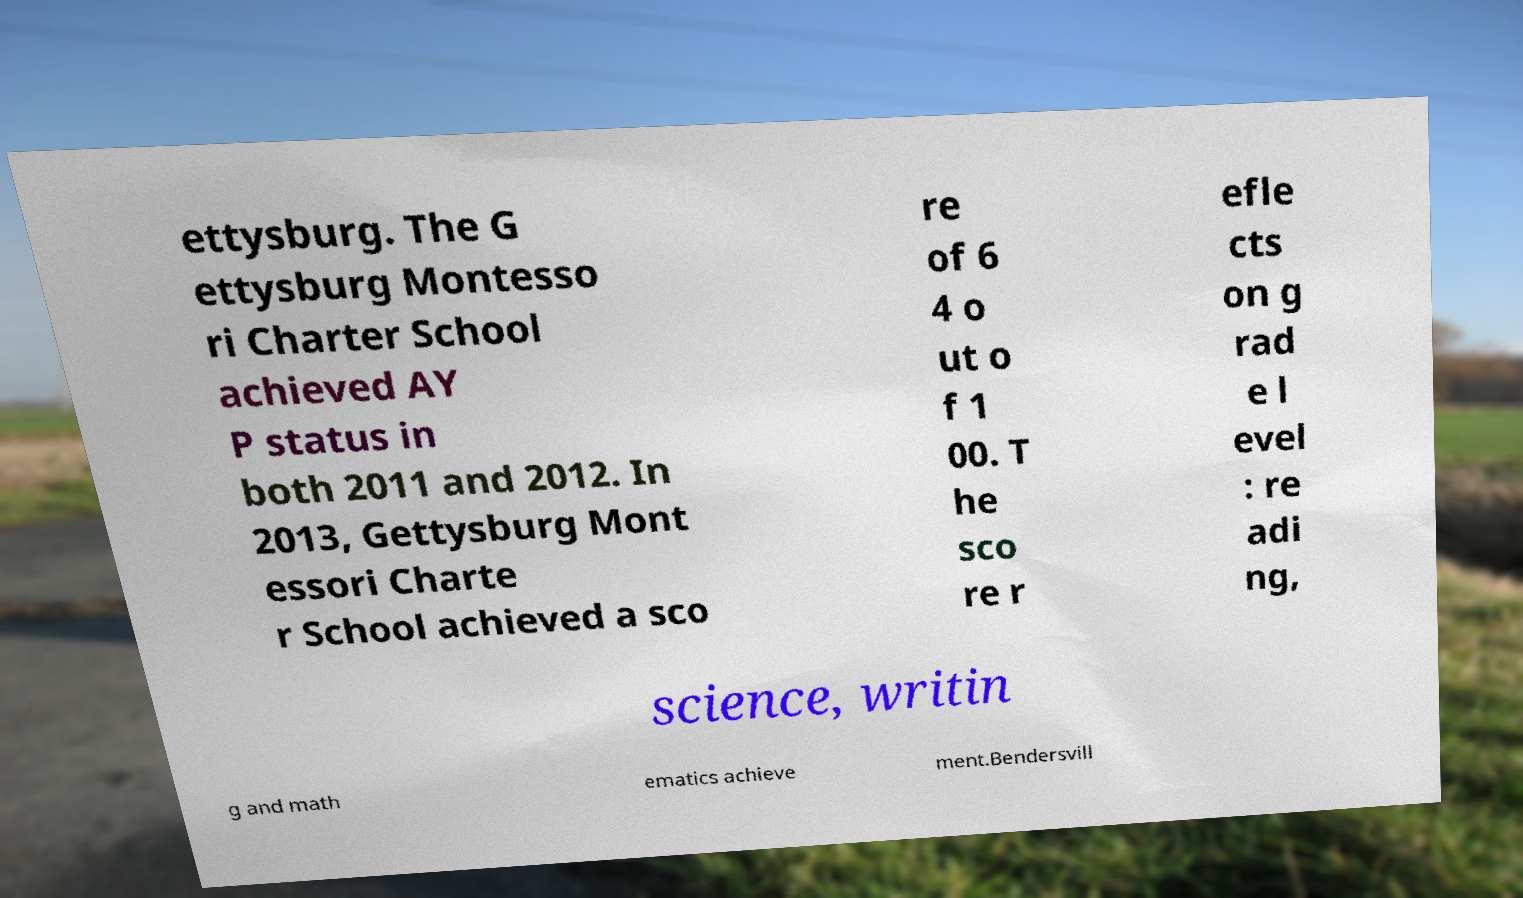What messages or text are displayed in this image? I need them in a readable, typed format. ettysburg. The G ettysburg Montesso ri Charter School achieved AY P status in both 2011 and 2012. In 2013, Gettysburg Mont essori Charte r School achieved a sco re of 6 4 o ut o f 1 00. T he sco re r efle cts on g rad e l evel : re adi ng, science, writin g and math ematics achieve ment.Bendersvill 